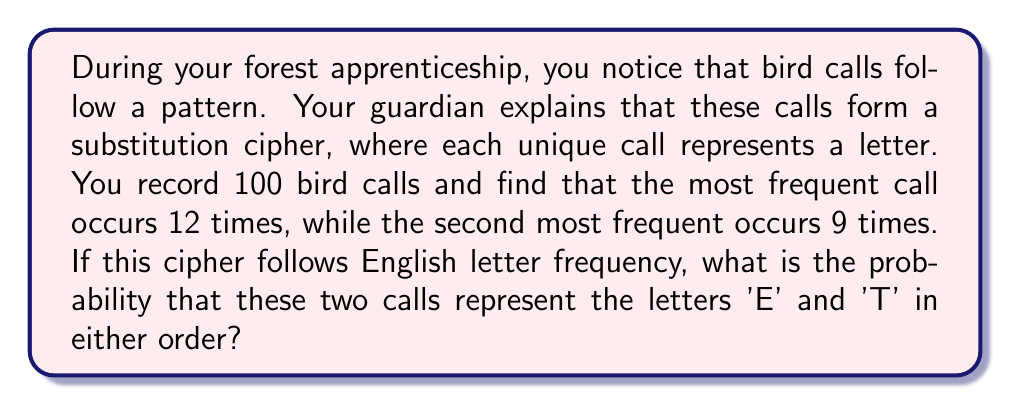Help me with this question. Let's approach this step-by-step:

1) In English, 'E' is the most common letter, followed by 'T'.

2) We need to calculate the probability of two events:
   a) The most frequent call (12 times) represents 'E', and the second most frequent (9 times) represents 'T'.
   b) The most frequent call represents 'T', and the second most frequent represents 'E'.

3) Let's calculate the probability of each event:

   a) P(E = 12, T = 9) = $\frac{12}{100} \cdot \frac{9}{99} = \frac{108}{9900} = \frac{27}{2475}$

   b) P(T = 12, E = 9) = $\frac{12}{100} \cdot \frac{9}{99} = \frac{108}{9900} = \frac{27}{2475}$

4) The total probability is the sum of these two mutually exclusive events:

   P(total) = P(E = 12, T = 9) + P(T = 12, E = 9)
            = $\frac{27}{2475} + \frac{27}{2475}$
            = $\frac{54}{2475}$
            = $\frac{2}{99}$
            ≈ 0.0202 or about 2.02%
Answer: $\frac{2}{99}$ 